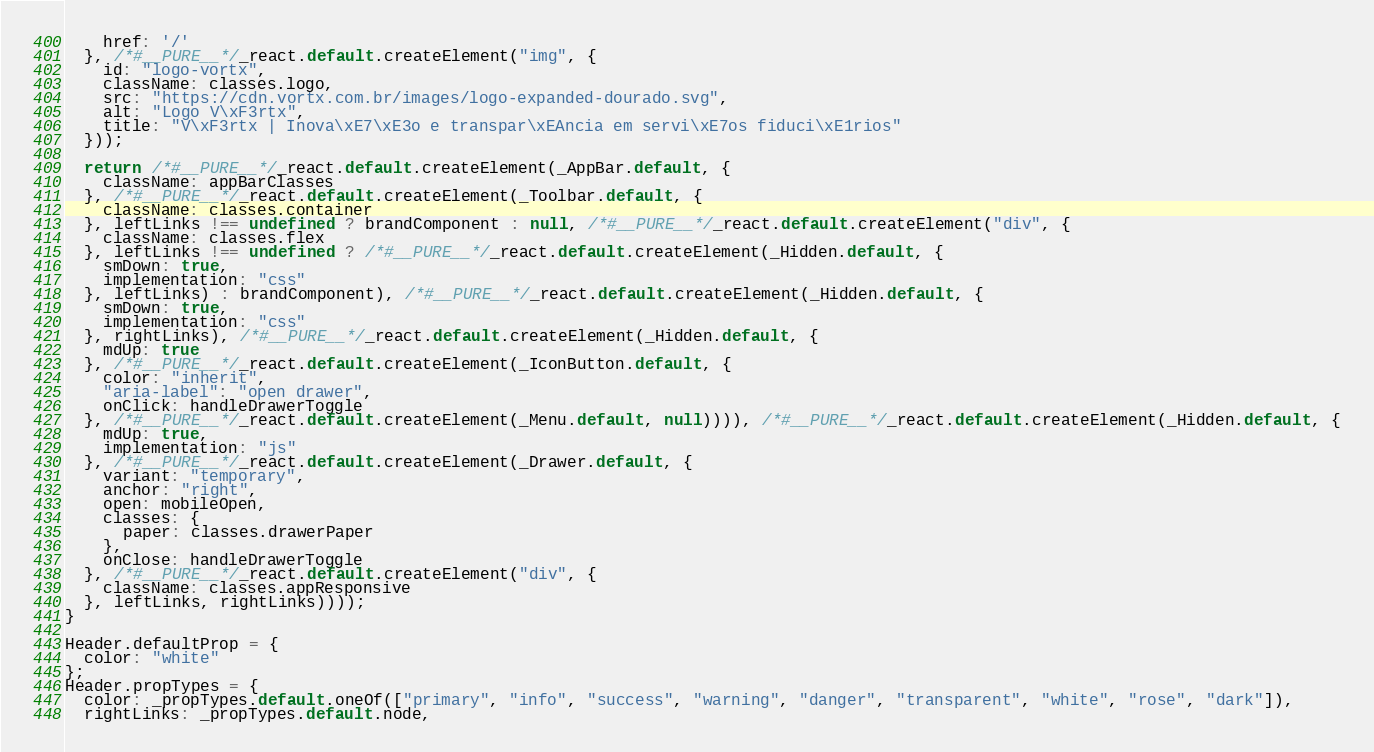Convert code to text. <code><loc_0><loc_0><loc_500><loc_500><_JavaScript_>    href: '/'
  }, /*#__PURE__*/_react.default.createElement("img", {
    id: "logo-vortx",
    className: classes.logo,
    src: "https://cdn.vortx.com.br/images/logo-expanded-dourado.svg",
    alt: "Logo V\xF3rtx",
    title: "V\xF3rtx | Inova\xE7\xE3o e transpar\xEAncia em servi\xE7os fiduci\xE1rios"
  }));

  return /*#__PURE__*/_react.default.createElement(_AppBar.default, {
    className: appBarClasses
  }, /*#__PURE__*/_react.default.createElement(_Toolbar.default, {
    className: classes.container
  }, leftLinks !== undefined ? brandComponent : null, /*#__PURE__*/_react.default.createElement("div", {
    className: classes.flex
  }, leftLinks !== undefined ? /*#__PURE__*/_react.default.createElement(_Hidden.default, {
    smDown: true,
    implementation: "css"
  }, leftLinks) : brandComponent), /*#__PURE__*/_react.default.createElement(_Hidden.default, {
    smDown: true,
    implementation: "css"
  }, rightLinks), /*#__PURE__*/_react.default.createElement(_Hidden.default, {
    mdUp: true
  }, /*#__PURE__*/_react.default.createElement(_IconButton.default, {
    color: "inherit",
    "aria-label": "open drawer",
    onClick: handleDrawerToggle
  }, /*#__PURE__*/_react.default.createElement(_Menu.default, null)))), /*#__PURE__*/_react.default.createElement(_Hidden.default, {
    mdUp: true,
    implementation: "js"
  }, /*#__PURE__*/_react.default.createElement(_Drawer.default, {
    variant: "temporary",
    anchor: "right",
    open: mobileOpen,
    classes: {
      paper: classes.drawerPaper
    },
    onClose: handleDrawerToggle
  }, /*#__PURE__*/_react.default.createElement("div", {
    className: classes.appResponsive
  }, leftLinks, rightLinks))));
}

Header.defaultProp = {
  color: "white"
};
Header.propTypes = {
  color: _propTypes.default.oneOf(["primary", "info", "success", "warning", "danger", "transparent", "white", "rose", "dark"]),
  rightLinks: _propTypes.default.node,</code> 